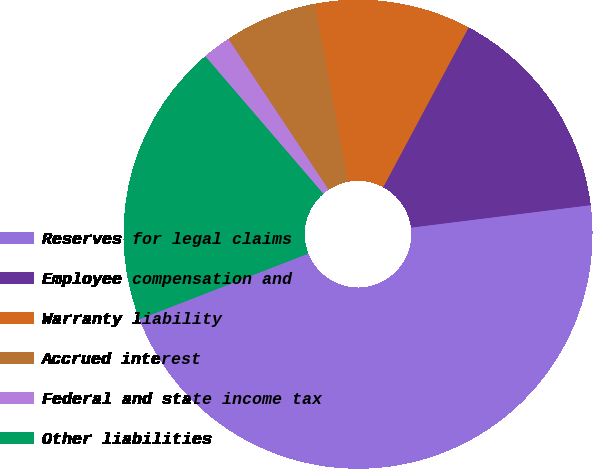<chart> <loc_0><loc_0><loc_500><loc_500><pie_chart><fcel>Reserves for legal claims<fcel>Employee compensation and<fcel>Warranty liability<fcel>Accrued interest<fcel>Federal and state income tax<fcel>Other liabilities<nl><fcel>46.08%<fcel>15.2%<fcel>10.78%<fcel>6.37%<fcel>1.96%<fcel>19.61%<nl></chart> 